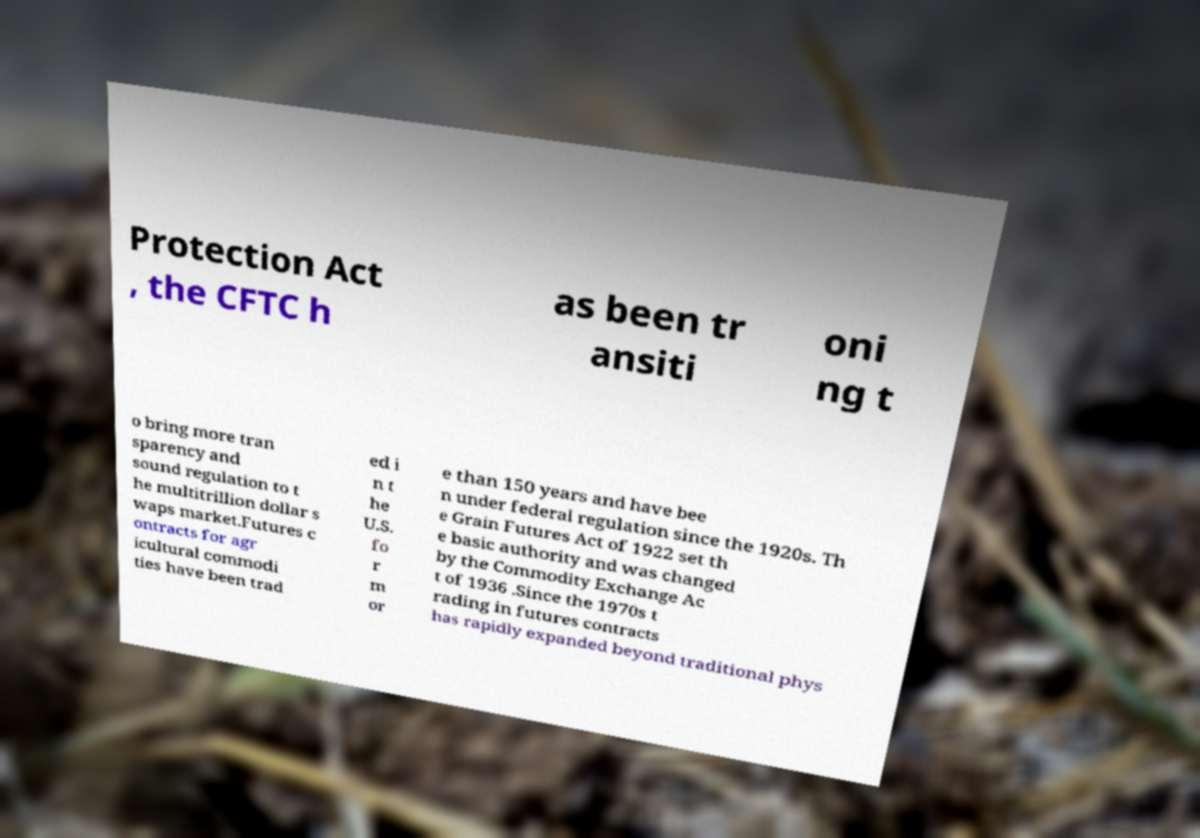Please read and relay the text visible in this image. What does it say? Protection Act , the CFTC h as been tr ansiti oni ng t o bring more tran sparency and sound regulation to t he multitrillion dollar s waps market.Futures c ontracts for agr icultural commodi ties have been trad ed i n t he U.S. fo r m or e than 150 years and have bee n under federal regulation since the 1920s. Th e Grain Futures Act of 1922 set th e basic authority and was changed by the Commodity Exchange Ac t of 1936 .Since the 1970s t rading in futures contracts has rapidly expanded beyond traditional phys 